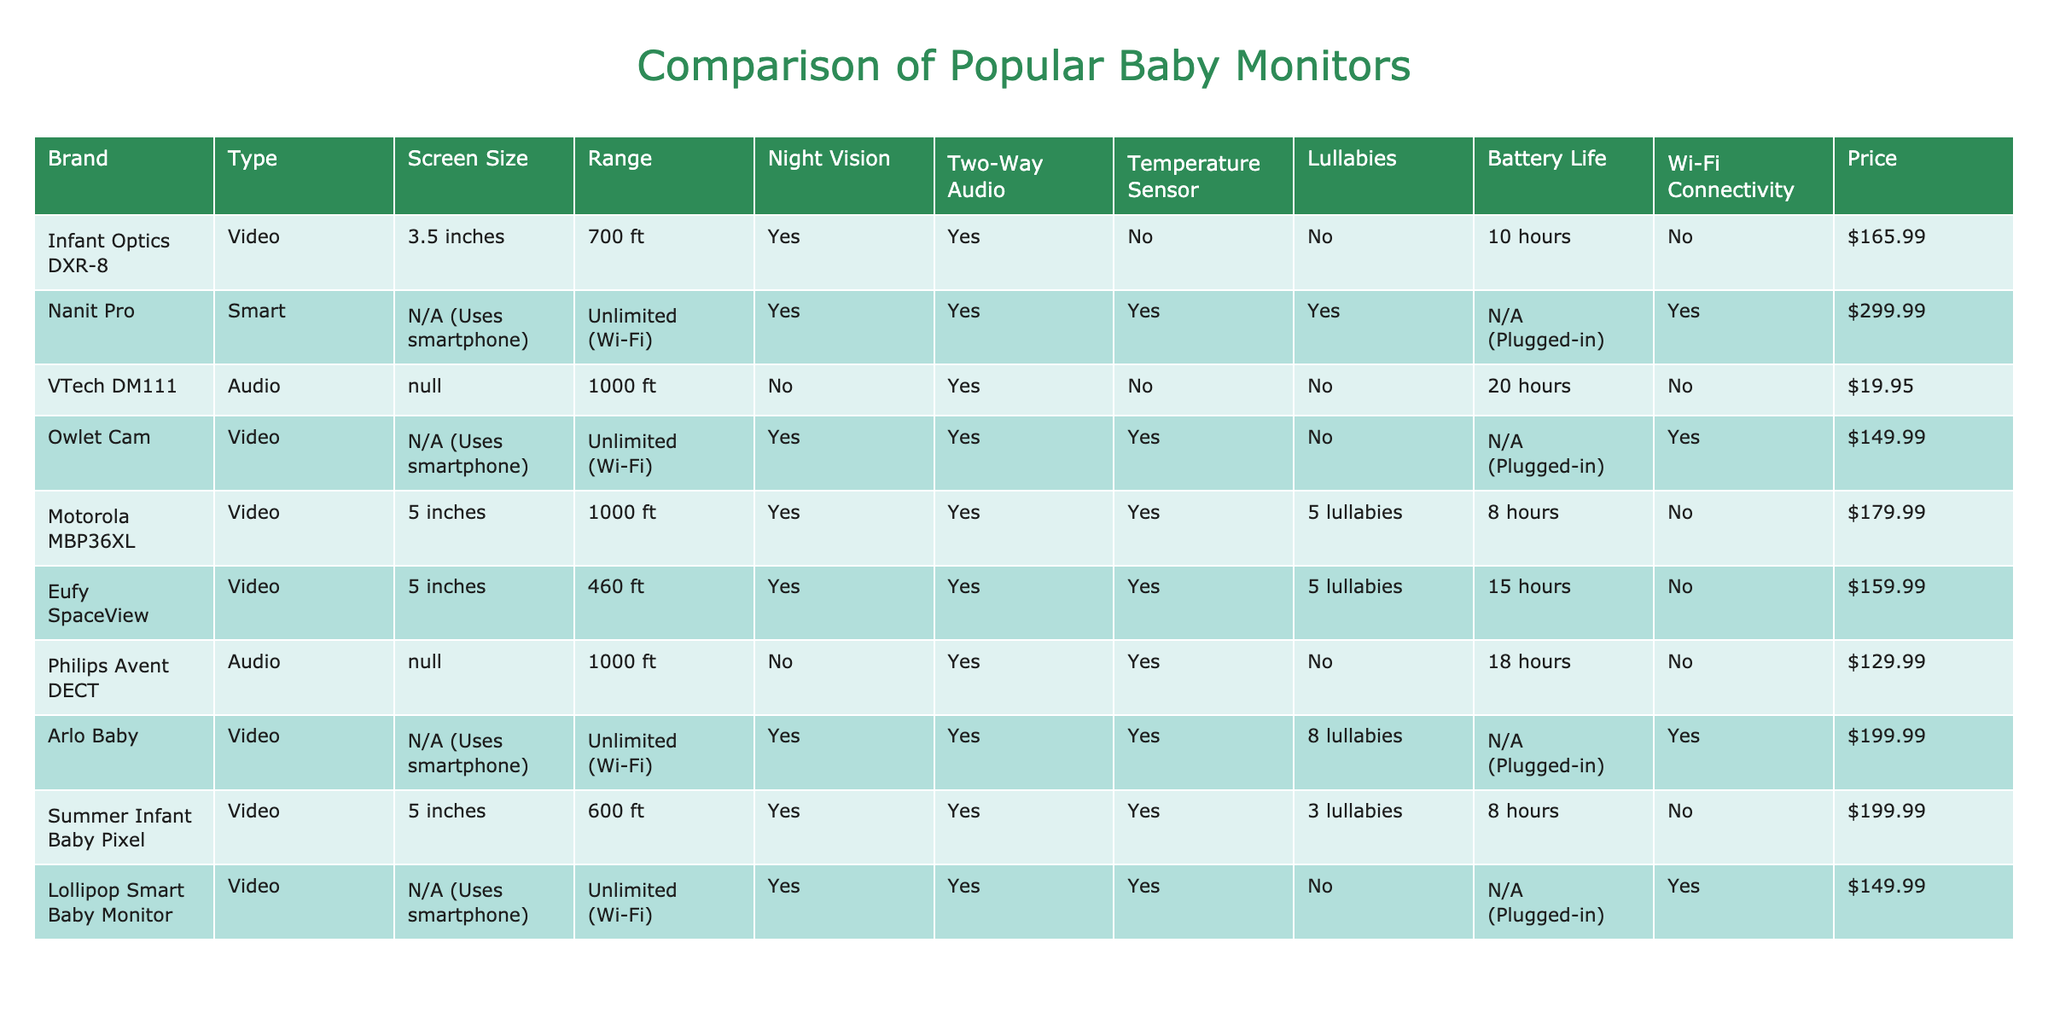What is the price of the Eufy SpaceView monitor? The price of the Eufy SpaceView monitor is listed in the table under the "Price" column. It shows $159.99.
Answer: $159.99 How many monitors have a screen size of 5 inches? By counting the entries in the "Screen Size" column, there are three monitors (Motorola MBP36XL, Summer Infant Baby Pixel, and Eufy SpaceView) with a screen size of 5 inches.
Answer: 3 Does the VTech DM111 monitor have night vision? The "Night Vision" column shows "No" for the VTech DM111 monitor, indicating it does not have this feature.
Answer: No Which monitor has the longest battery life? The "Battery Life" column shows that the VTech DM111 monitor has the longest battery life of 20 hours, compared to others.
Answer: 20 hours How much more expensive is the Nanit Pro than the Philips Avent DECT? The price of the Nanit Pro is $299.99 and the price of the Philips Avent DECT is $129.99. The difference is $299.99 - $129.99 = $170.00.
Answer: $170.00 How many baby monitors have two-way audio but do not have lullabies? Looking at the "Two-Way Audio" and "Lullabies" columns, only the Infant Optics DXR-8 have two-way audio and do not have lullabies. Therefore, there is 1 such monitor.
Answer: 1 What percentage of the listed monitors have Wi-Fi connectivity? There are 7 monitors in total, and 5 of them have Wi-Fi connectivity. The percentage is calculated as (5/7) * 100 = approximately 71.43%.
Answer: 71.43% Which monitor offers the most lullabies? From the "Lullabies" column, the Arlo Baby monitor provides 8 lullabies, which is the highest count among the listed monitors.
Answer: Arlo Baby Is there any monitor that has both two-way audio and temperature sensor? The table shows that Nanit Pro and Owlet Cam have both two-way audio and a temperature sensor, indicating that 2 monitors fulfill this condition.
Answer: Yes What is the average price of video monitors in the table? The prices for video monitors are $165.99 (Infant Optics DXR-8), $149.99 (Owlet Cam), $179.99 (Motorola MBP36XL), $159.99 (Eufy SpaceView), $199.99 (Arlo Baby), and $199.99 (Summer Infant Baby Pixel). The average is calculated as (165.99 + 149.99 + 179.99 + 159.99 + 199.99 + 199.99) / 6 = $175.32.
Answer: $175.32 